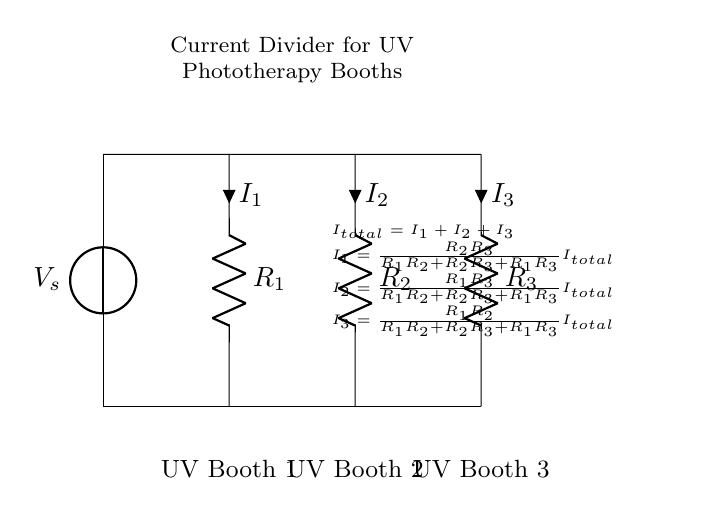What is the total current in the circuit? The total current is represented by \( I_{total} \) and is the sum of all individual currents \( I_1, I_2, \) and \( I_3 \).
Answer: I_total What component type is used in this circuit? The components used in this circuit are resistors, indicated by the symbol R.
Answer: Resistors How many UV booths are represented in this circuit? There are three UV booths, as evidenced by the three labels corresponding to the resistors in the circuit.
Answer: Three What are the values of the currents in relation to total current? The currents \( I_1, I_2, \) and \( I_3 \) are calculated based on the resistance values and the total current according to the current divider formulas shown in the circuit note.
Answer: Proportional What is the formula to calculate \( I_1 \)? \( I_1 \) is calculated using the formula \( I_1 = \frac{R_2R_3}{R_1R_2 + R_2R_3 + R_1R_3} I_{total} \), which incorporates the resistances of the other resistors and total current.
Answer: I_1 formula What is the purpose of this circuit configuration? The configuration serves as a current divider to balance energy consumption across the UV booths, ensuring even distribution of current for effective treatment.
Answer: Current balancing 